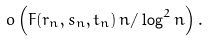Convert formula to latex. <formula><loc_0><loc_0><loc_500><loc_500>o \left ( F ( r _ { n } , s _ { n } , t _ { n } ) \, n / \log ^ { 2 } n \right ) .</formula> 